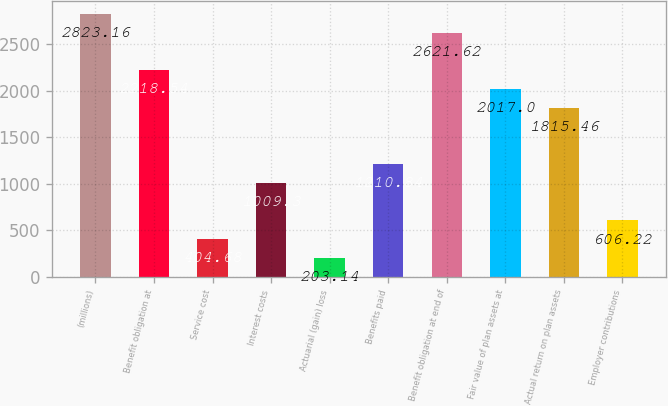<chart> <loc_0><loc_0><loc_500><loc_500><bar_chart><fcel>(millions)<fcel>Benefit obligation at<fcel>Service cost<fcel>Interest costs<fcel>Actuarial (gain) loss<fcel>Benefits paid<fcel>Benefit obligation at end of<fcel>Fair value of plan assets at<fcel>Actual return on plan assets<fcel>Employer contributions<nl><fcel>2823.16<fcel>2218.54<fcel>404.68<fcel>1009.3<fcel>203.14<fcel>1210.84<fcel>2621.62<fcel>2017<fcel>1815.46<fcel>606.22<nl></chart> 